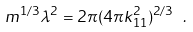Convert formula to latex. <formula><loc_0><loc_0><loc_500><loc_500>m ^ { 1 / 3 } \lambda ^ { 2 } = 2 \pi ( 4 \pi k _ { 1 1 } ^ { 2 } ) ^ { 2 / 3 } \ .</formula> 